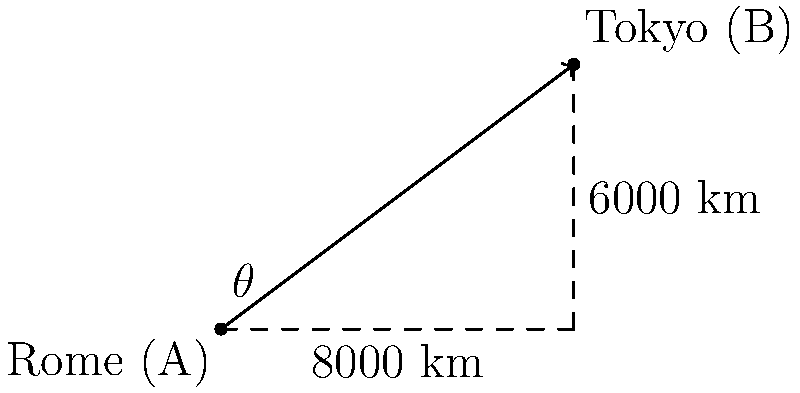As a retired diplomat, you're planning a special diplomatic flight from Rome to Tokyo. Given that the horizontal distance between the two cities is 8000 km and the vertical distance (accounting for Earth's curvature) is 6000 km, what is the angle of inclination ($\theta$) for the direct flight path? To find the angle of inclination, we can use the arctangent function. Here's how we solve it step-by-step:

1) We have a right triangle where:
   - The base (horizontal distance) is 8000 km
   - The height (vertical distance) is 6000 km
   - The angle we're looking for is $\theta$

2) In a right triangle, $\tan(\theta) = \frac{\text{opposite}}{\text{adjacent}}$

3) In this case:
   $\tan(\theta) = \frac{6000}{8000} = \frac{3}{4} = 0.75$

4) To find $\theta$, we need to take the inverse tangent (arctangent) of this value:

   $\theta = \arctan(0.75)$

5) Using a calculator or mathematical tables:

   $\theta \approx 36.87°$

Therefore, the angle of inclination for the diplomatic flight path is approximately 36.87°.
Answer: $36.87°$ 